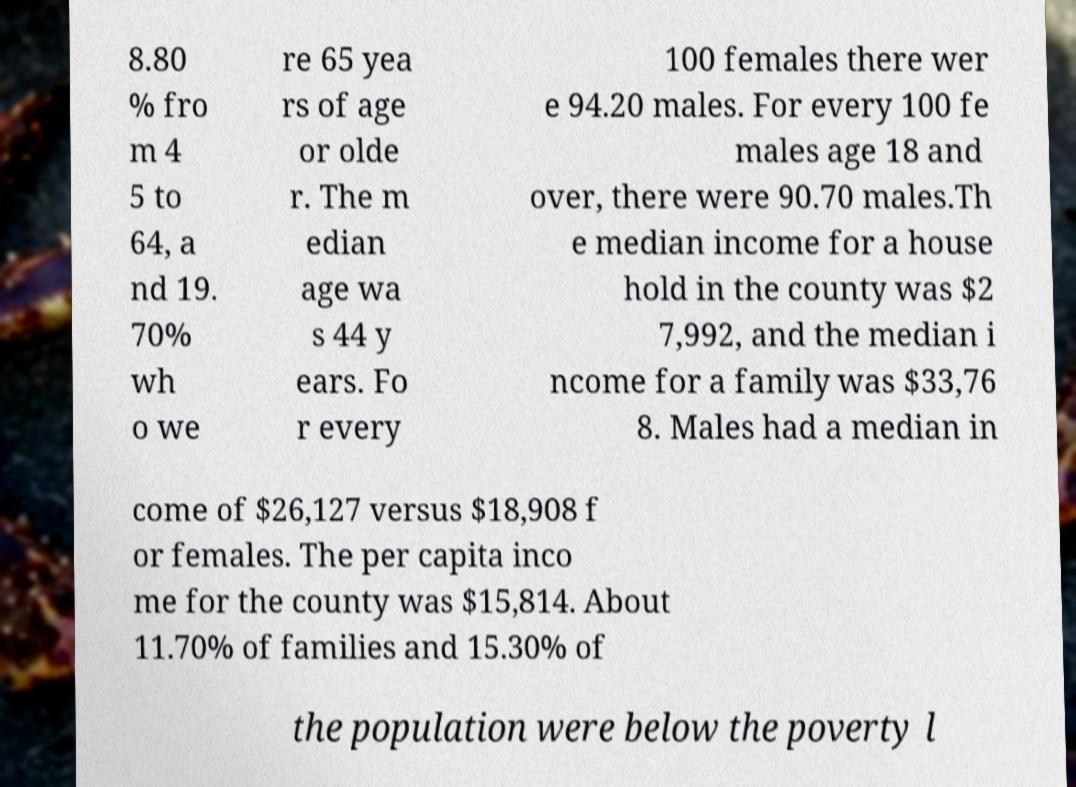Please identify and transcribe the text found in this image. 8.80 % fro m 4 5 to 64, a nd 19. 70% wh o we re 65 yea rs of age or olde r. The m edian age wa s 44 y ears. Fo r every 100 females there wer e 94.20 males. For every 100 fe males age 18 and over, there were 90.70 males.Th e median income for a house hold in the county was $2 7,992, and the median i ncome for a family was $33,76 8. Males had a median in come of $26,127 versus $18,908 f or females. The per capita inco me for the county was $15,814. About 11.70% of families and 15.30% of the population were below the poverty l 